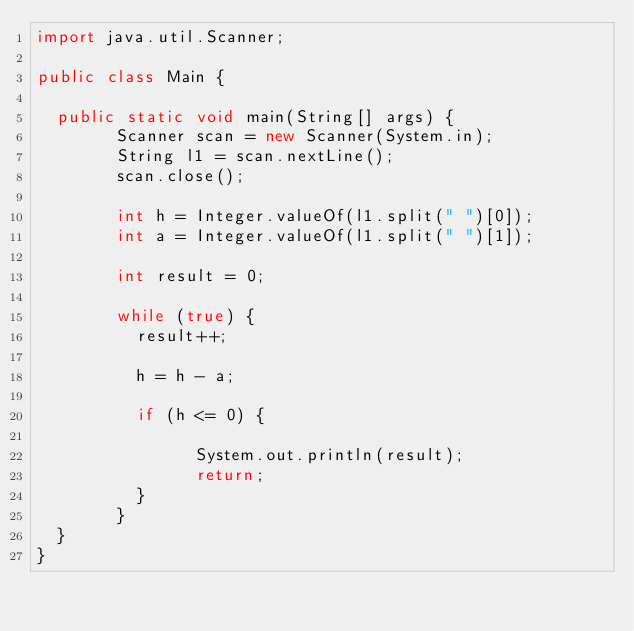<code> <loc_0><loc_0><loc_500><loc_500><_Java_>import java.util.Scanner;

public class Main {

	public static void main(String[] args) {
        Scanner scan = new Scanner(System.in);
        String l1 = scan.nextLine();
        scan.close();

        int h = Integer.valueOf(l1.split(" ")[0]);
        int a = Integer.valueOf(l1.split(" ")[1]);

        int result = 0;

        while (true) {
        	result++;

        	h = h - a;

        	if (h <= 0) {

                System.out.println(result);
                return;
        	}
        }
	}
}
</code> 